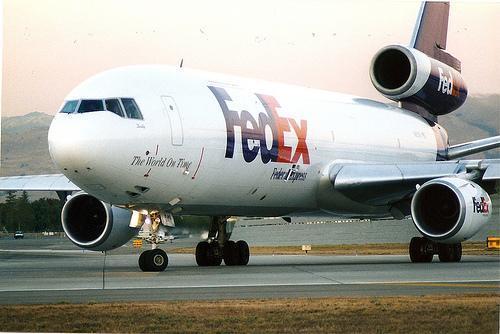How many planes are visible?
Give a very brief answer. 1. 